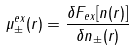<formula> <loc_0><loc_0><loc_500><loc_500>\mu ^ { e x } _ { \pm } ( r ) = \frac { \delta F _ { e x } [ n ( r ) ] } { \delta n _ { \pm } ( r ) }</formula> 